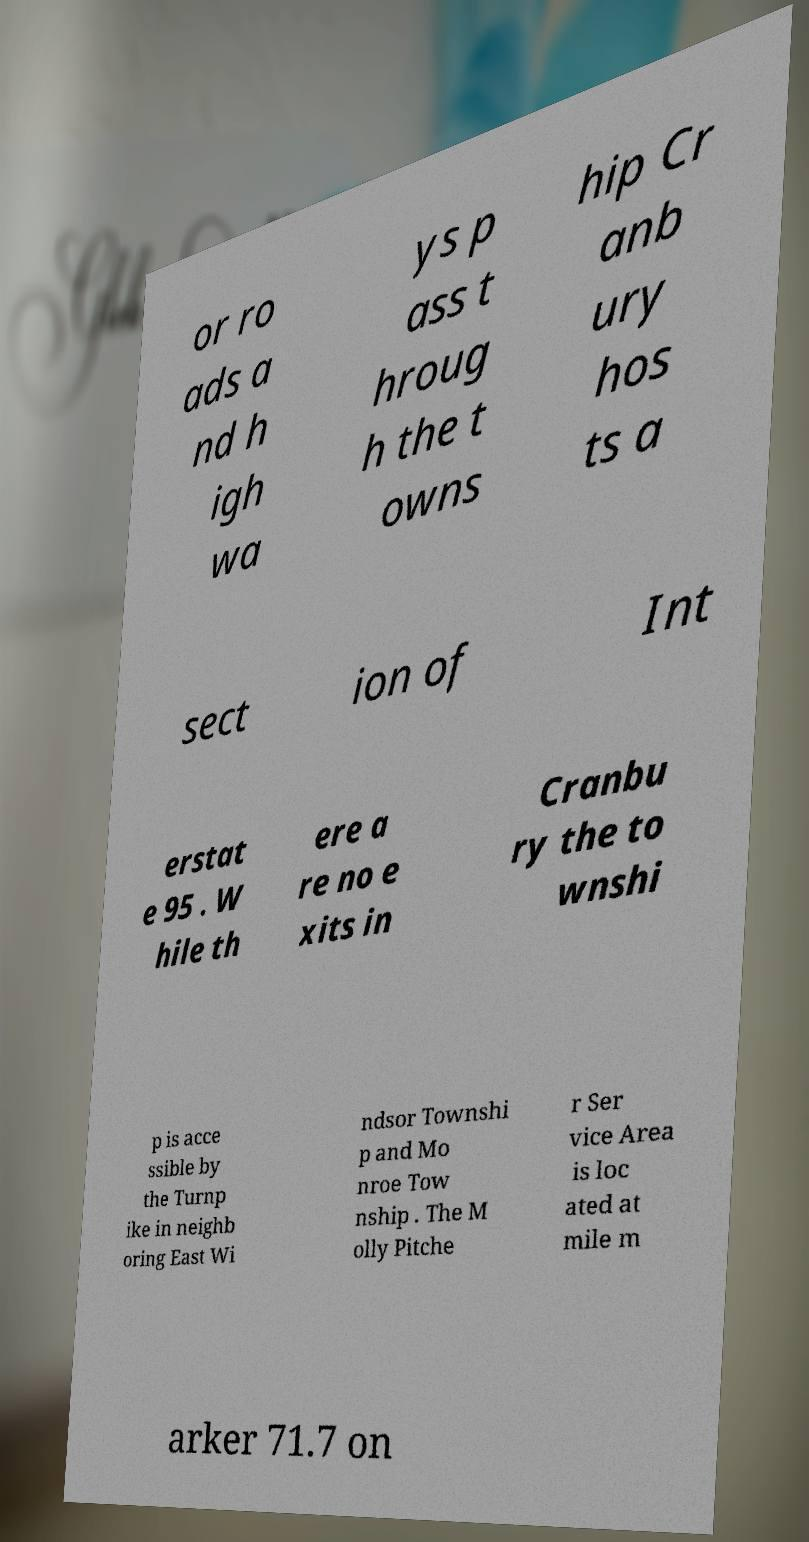Could you assist in decoding the text presented in this image and type it out clearly? or ro ads a nd h igh wa ys p ass t hroug h the t owns hip Cr anb ury hos ts a sect ion of Int erstat e 95 . W hile th ere a re no e xits in Cranbu ry the to wnshi p is acce ssible by the Turnp ike in neighb oring East Wi ndsor Townshi p and Mo nroe Tow nship . The M olly Pitche r Ser vice Area is loc ated at mile m arker 71.7 on 